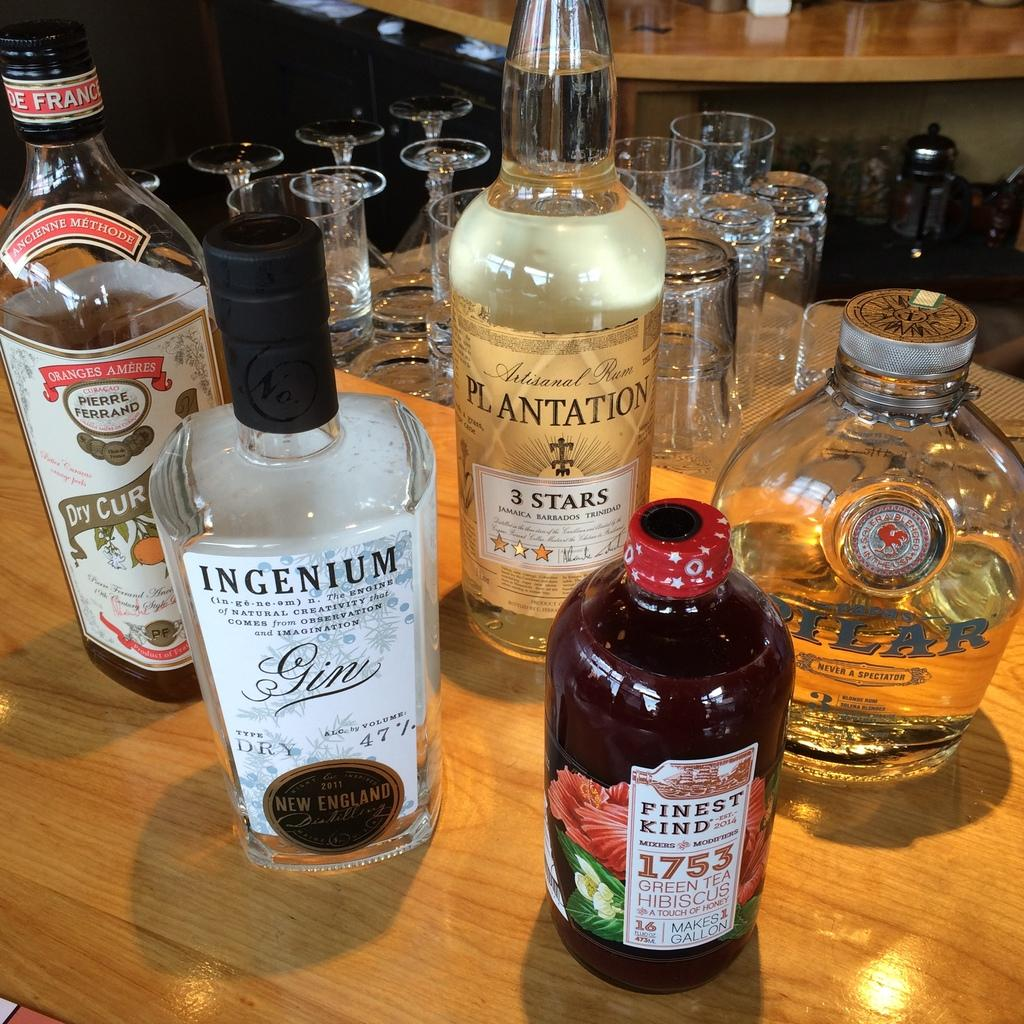<image>
Offer a succinct explanation of the picture presented. Five bottles of gin with the brands Plantation, Ingenium, Pilar, Finest Kind, and Pierre Ferrand sit on a table. 